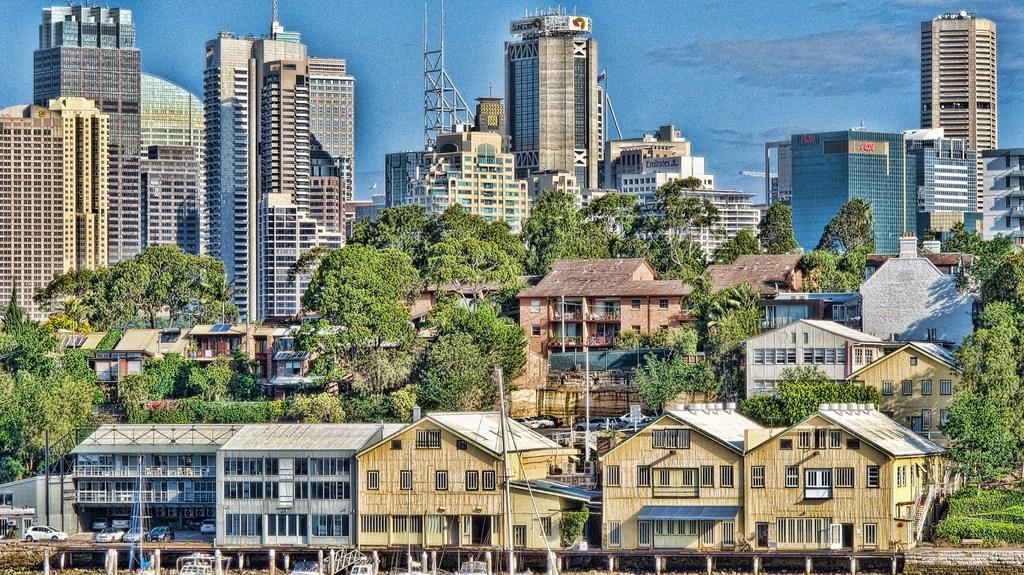What is the main subject of the image? The main subject of the image is a painting. What elements are depicted in the painting? The painting contains buildings and trees. What type of distribution is being used to display the painting in the image? There is no information provided about the distribution of the painting in the image, as the focus is on the content of the painting itself. 